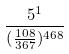<formula> <loc_0><loc_0><loc_500><loc_500>\frac { 5 ^ { 1 } } { ( \frac { 1 0 8 } { 3 6 7 } ) ^ { 4 6 8 } }</formula> 